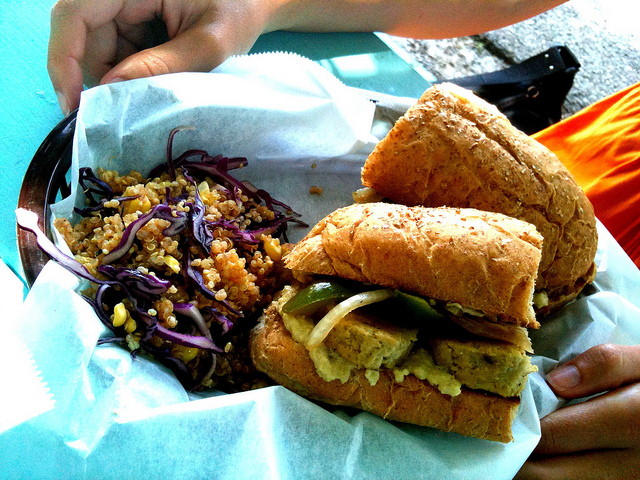What type of occasion would this meal be suitable for? This meal appears to be a lovely choice for a casual lunch or a light dinner, especially if someone is looking for a flavorful yet nutritious option. It would be well-suited for a picnic, as it appears easy to pack, or a quick grab-and-go meal during a busy day. The balance of vegetables and grains hints at a mindful choice, making it appropriate for health-conscious individuals or those who enjoy plant-based cuisine. 